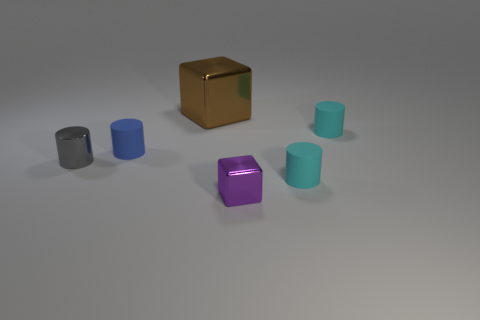Add 3 tiny purple objects. How many objects exist? 9 Subtract all blocks. How many objects are left? 4 Add 3 small gray shiny cylinders. How many small gray shiny cylinders are left? 4 Add 5 large brown blocks. How many large brown blocks exist? 6 Subtract 0 red cubes. How many objects are left? 6 Subtract all purple metal blocks. Subtract all brown matte cylinders. How many objects are left? 5 